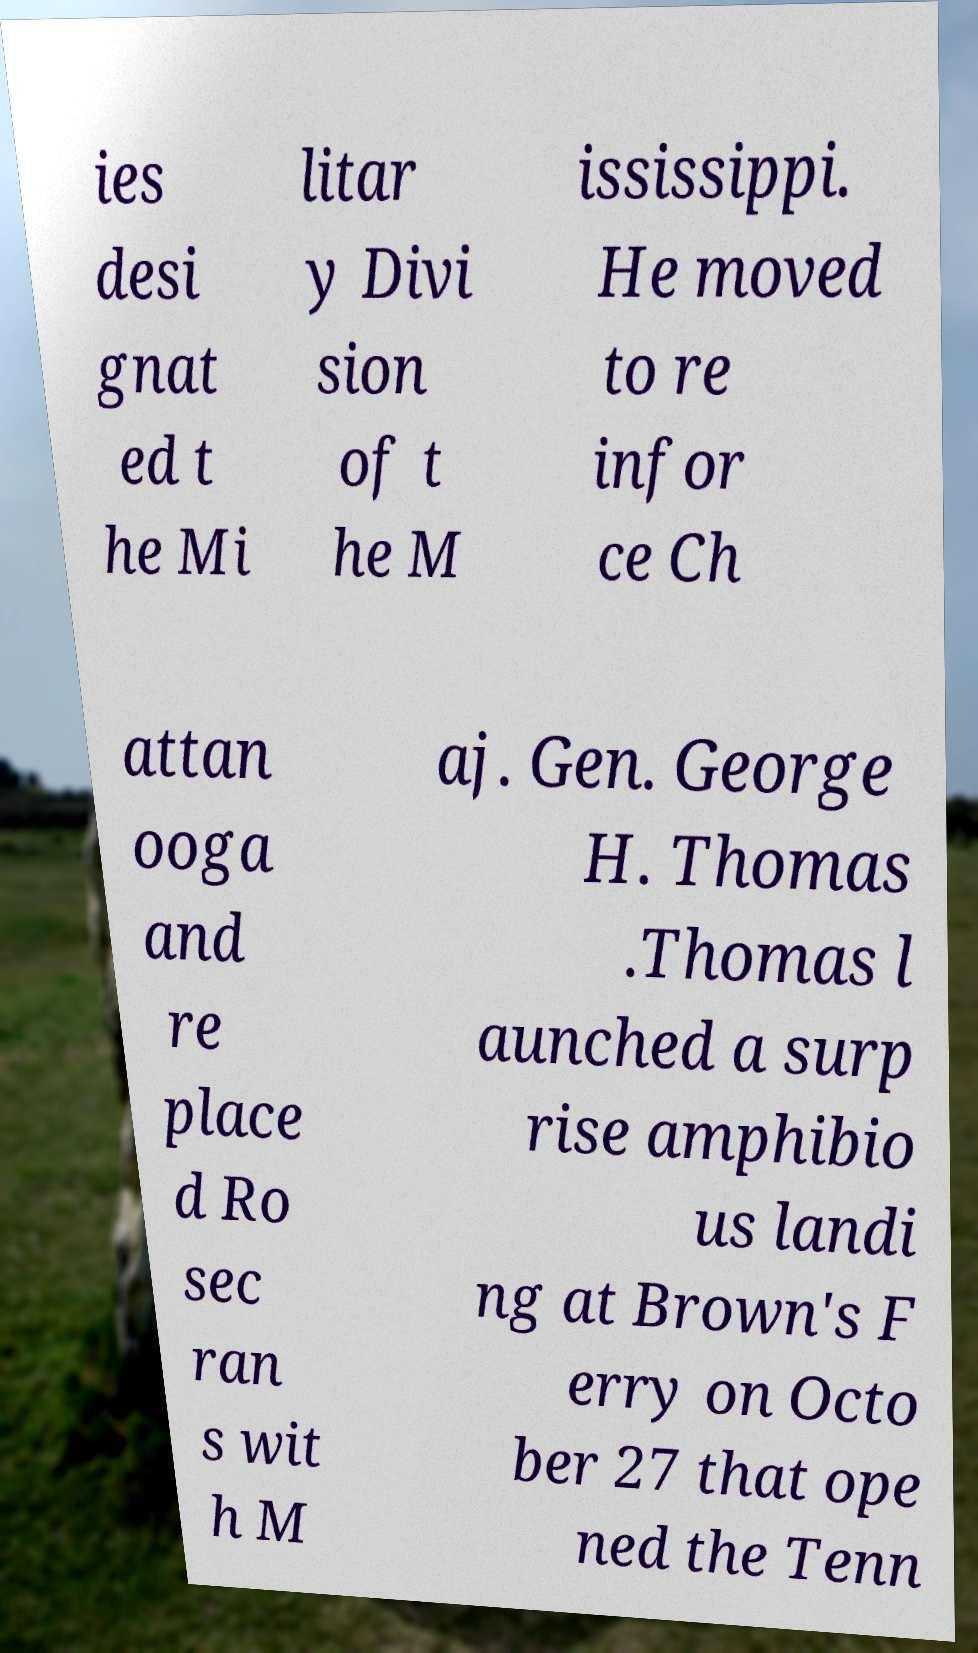For documentation purposes, I need the text within this image transcribed. Could you provide that? ies desi gnat ed t he Mi litar y Divi sion of t he M ississippi. He moved to re infor ce Ch attan ooga and re place d Ro sec ran s wit h M aj. Gen. George H. Thomas .Thomas l aunched a surp rise amphibio us landi ng at Brown's F erry on Octo ber 27 that ope ned the Tenn 